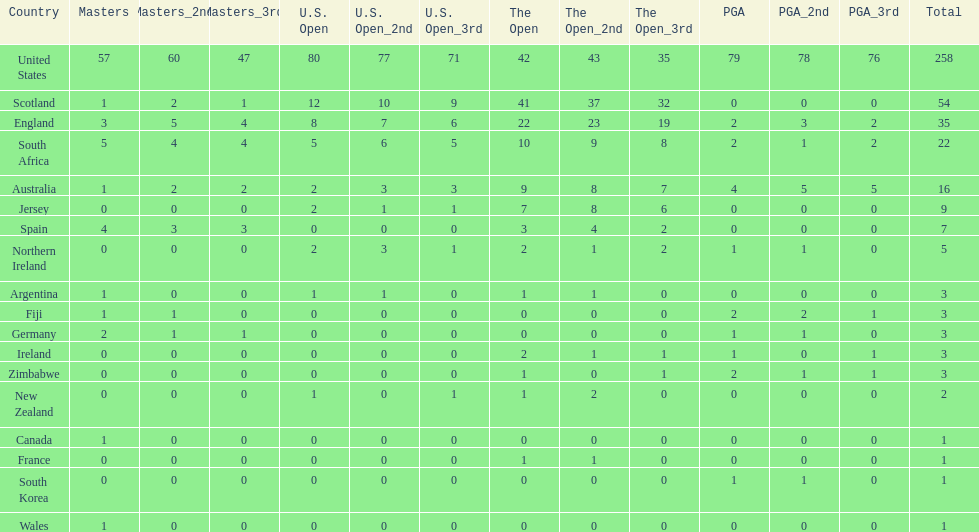Which country has the most pga championships. United States. 